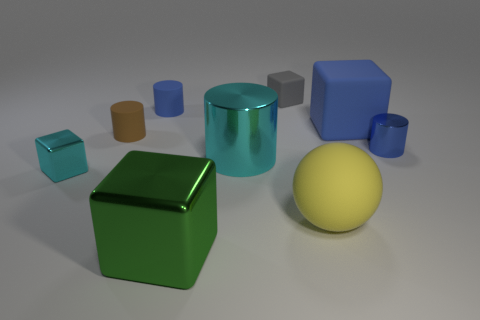How many yellow spheres have the same material as the tiny brown thing? There is one yellow sphere in the image, and it appears to share the same matte finish as the small brown cylinder. 